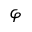<formula> <loc_0><loc_0><loc_500><loc_500>\varphi</formula> 